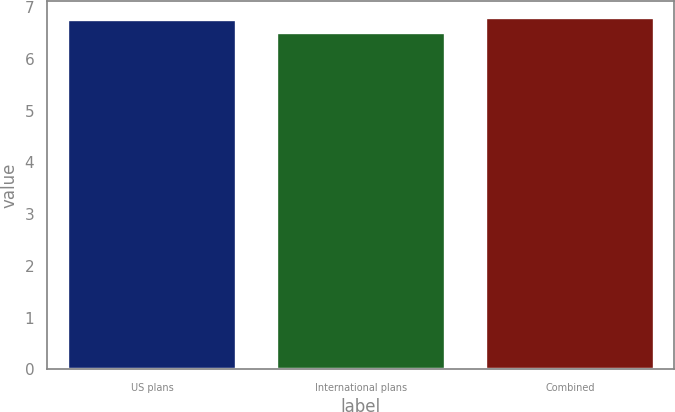Convert chart to OTSL. <chart><loc_0><loc_0><loc_500><loc_500><bar_chart><fcel>US plans<fcel>International plans<fcel>Combined<nl><fcel>6.75<fcel>6.5<fcel>6.78<nl></chart> 